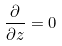Convert formula to latex. <formula><loc_0><loc_0><loc_500><loc_500>\frac { \partial } { \partial z } = 0</formula> 